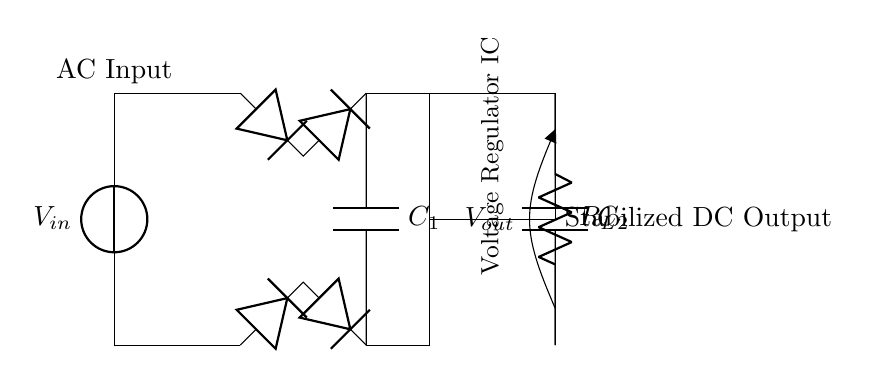What is the input voltage of the circuit? The input voltage is denoted as \( V_{in} \), which is the voltage supplied to the circuit from the AC source.
Answer: V_{in} What type of rectifier is used in this circuit? The circuit diagram features a bridge rectifier, indicated by the arrangement of four diodes that convert AC to DC.
Answer: Bridge rectifier How many capacitors are present in the circuit? The circuit diagram shows two capacitors: \( C_1 \) (the smoothing capacitor) and \( C_2 \) (the output capacitor).
Answer: Two What is the purpose of the voltage regulator IC? The voltage regulator IC is responsible for maintaining a stable output voltage, ensuring that sensitive electronic devices receive a consistent DC voltage.
Answer: Stabilization What voltage is expected at the output of the circuit? The output voltage, denoted as \( V_{out} \), is the stabilized DC voltage produced by the circuit after processing the input AC voltage through the transformer, rectifier, and regulator.
Answer: V_{out} What component follows the smoothing capacitor in the circuit? After the smoothing capacitor \( C_1 \), the voltage regulator IC follows, which is crucial for regularizing the voltage level to protect devices from fluctuations.
Answer: Voltage regulator IC What is the load component labeled in the circuit? The load component is labeled as \( R_L \), which represents the resistor that simulates the load connected to the output of the voltage regulator.
Answer: R_L 